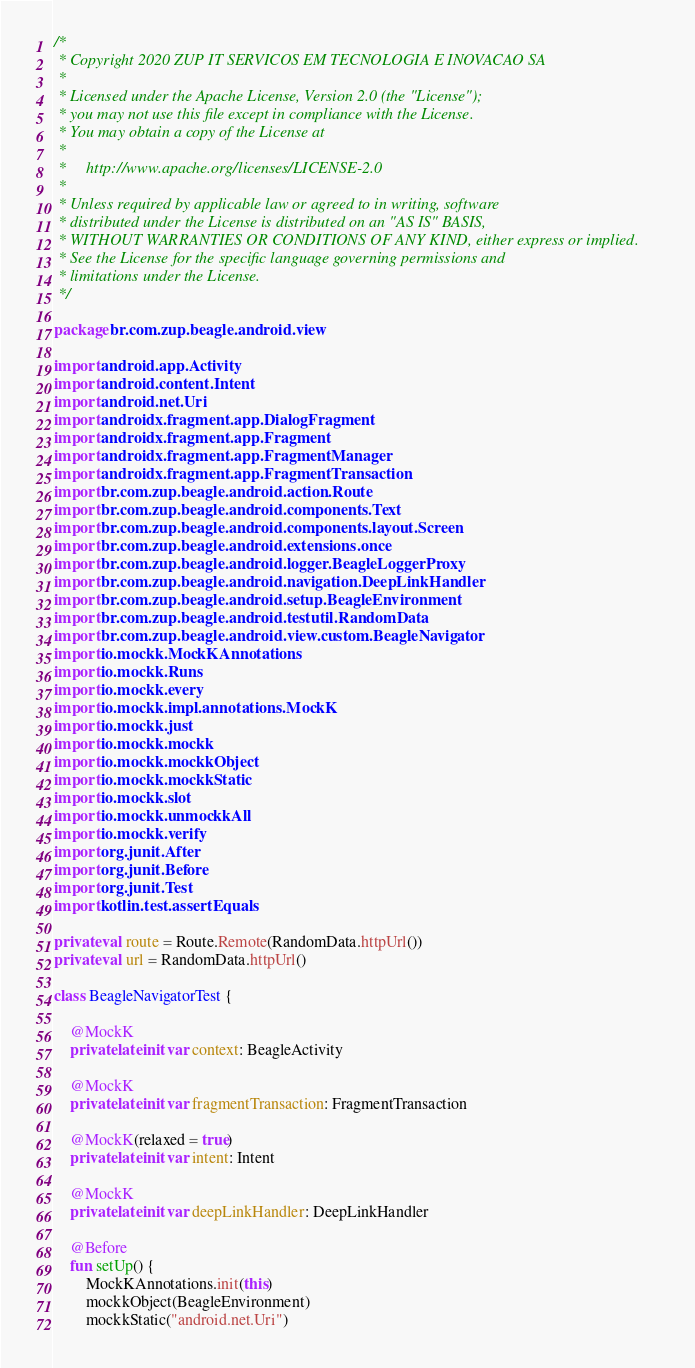<code> <loc_0><loc_0><loc_500><loc_500><_Kotlin_>/*
 * Copyright 2020 ZUP IT SERVICOS EM TECNOLOGIA E INOVACAO SA
 *
 * Licensed under the Apache License, Version 2.0 (the "License");
 * you may not use this file except in compliance with the License.
 * You may obtain a copy of the License at
 *
 *     http://www.apache.org/licenses/LICENSE-2.0
 *
 * Unless required by applicable law or agreed to in writing, software
 * distributed under the License is distributed on an "AS IS" BASIS,
 * WITHOUT WARRANTIES OR CONDITIONS OF ANY KIND, either express or implied.
 * See the License for the specific language governing permissions and
 * limitations under the License.
 */

package br.com.zup.beagle.android.view

import android.app.Activity
import android.content.Intent
import android.net.Uri
import androidx.fragment.app.DialogFragment
import androidx.fragment.app.Fragment
import androidx.fragment.app.FragmentManager
import androidx.fragment.app.FragmentTransaction
import br.com.zup.beagle.android.action.Route
import br.com.zup.beagle.android.components.Text
import br.com.zup.beagle.android.components.layout.Screen
import br.com.zup.beagle.android.extensions.once
import br.com.zup.beagle.android.logger.BeagleLoggerProxy
import br.com.zup.beagle.android.navigation.DeepLinkHandler
import br.com.zup.beagle.android.setup.BeagleEnvironment
import br.com.zup.beagle.android.testutil.RandomData
import br.com.zup.beagle.android.view.custom.BeagleNavigator
import io.mockk.MockKAnnotations
import io.mockk.Runs
import io.mockk.every
import io.mockk.impl.annotations.MockK
import io.mockk.just
import io.mockk.mockk
import io.mockk.mockkObject
import io.mockk.mockkStatic
import io.mockk.slot
import io.mockk.unmockkAll
import io.mockk.verify
import org.junit.After
import org.junit.Before
import org.junit.Test
import kotlin.test.assertEquals

private val route = Route.Remote(RandomData.httpUrl())
private val url = RandomData.httpUrl()

class BeagleNavigatorTest {

    @MockK
    private lateinit var context: BeagleActivity

    @MockK
    private lateinit var fragmentTransaction: FragmentTransaction

    @MockK(relaxed = true)
    private lateinit var intent: Intent

    @MockK
    private lateinit var deepLinkHandler: DeepLinkHandler

    @Before
    fun setUp() {
        MockKAnnotations.init(this)
        mockkObject(BeagleEnvironment)
        mockkStatic("android.net.Uri")
</code> 